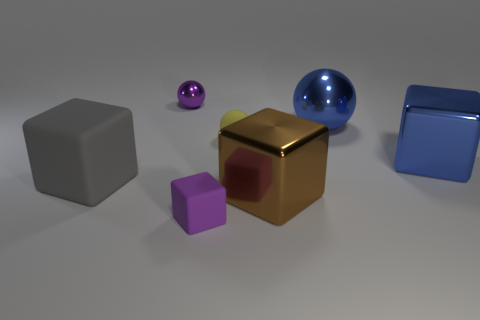There is a big metallic object on the right side of the large ball; does it have the same shape as the tiny purple object that is behind the large ball?
Your answer should be compact. No. Are any large blue rubber cylinders visible?
Make the answer very short. No. There is a ball that is the same size as the brown object; what color is it?
Your answer should be very brief. Blue. How many blue metal things have the same shape as the gray matte object?
Offer a very short reply. 1. Is the large blue thing that is left of the blue cube made of the same material as the small yellow object?
Give a very brief answer. No. What number of cylinders are either small yellow things or brown shiny objects?
Your response must be concise. 0. There is a small matte thing behind the big object that is to the left of the purple object that is behind the blue block; what shape is it?
Make the answer very short. Sphere. What is the shape of the big thing that is the same color as the large ball?
Provide a short and direct response. Cube. What number of rubber balls are the same size as the purple rubber object?
Provide a succinct answer. 1. There is a brown metallic cube on the left side of the big blue metallic block; is there a purple matte thing that is on the right side of it?
Give a very brief answer. No. 